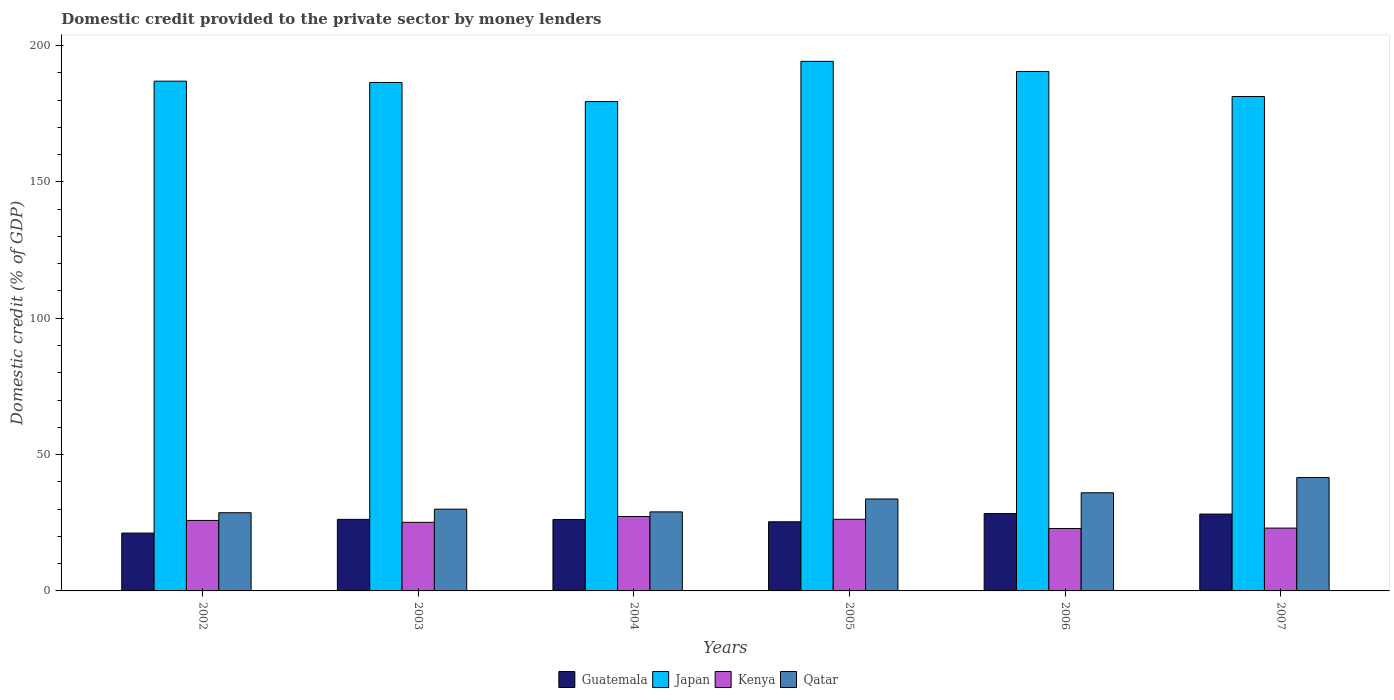Are the number of bars per tick equal to the number of legend labels?
Keep it short and to the point. Yes. What is the label of the 3rd group of bars from the left?
Your response must be concise. 2004. In how many cases, is the number of bars for a given year not equal to the number of legend labels?
Your answer should be very brief. 0. What is the domestic credit provided to the private sector by money lenders in Japan in 2004?
Your answer should be very brief. 179.48. Across all years, what is the maximum domestic credit provided to the private sector by money lenders in Guatemala?
Your answer should be very brief. 28.36. Across all years, what is the minimum domestic credit provided to the private sector by money lenders in Japan?
Your response must be concise. 179.48. In which year was the domestic credit provided to the private sector by money lenders in Japan minimum?
Your answer should be very brief. 2004. What is the total domestic credit provided to the private sector by money lenders in Qatar in the graph?
Give a very brief answer. 198.95. What is the difference between the domestic credit provided to the private sector by money lenders in Qatar in 2003 and that in 2004?
Provide a short and direct response. 1. What is the difference between the domestic credit provided to the private sector by money lenders in Guatemala in 2007 and the domestic credit provided to the private sector by money lenders in Japan in 2003?
Provide a short and direct response. -158.29. What is the average domestic credit provided to the private sector by money lenders in Kenya per year?
Your answer should be very brief. 25.08. In the year 2003, what is the difference between the domestic credit provided to the private sector by money lenders in Kenya and domestic credit provided to the private sector by money lenders in Qatar?
Your answer should be very brief. -4.83. In how many years, is the domestic credit provided to the private sector by money lenders in Guatemala greater than 120 %?
Provide a succinct answer. 0. What is the ratio of the domestic credit provided to the private sector by money lenders in Guatemala in 2002 to that in 2006?
Keep it short and to the point. 0.75. Is the domestic credit provided to the private sector by money lenders in Qatar in 2003 less than that in 2007?
Ensure brevity in your answer.  Yes. What is the difference between the highest and the second highest domestic credit provided to the private sector by money lenders in Qatar?
Provide a short and direct response. 5.58. What is the difference between the highest and the lowest domestic credit provided to the private sector by money lenders in Japan?
Your answer should be very brief. 14.74. Is the sum of the domestic credit provided to the private sector by money lenders in Japan in 2006 and 2007 greater than the maximum domestic credit provided to the private sector by money lenders in Qatar across all years?
Ensure brevity in your answer.  Yes. What does the 1st bar from the left in 2007 represents?
Provide a succinct answer. Guatemala. Is it the case that in every year, the sum of the domestic credit provided to the private sector by money lenders in Qatar and domestic credit provided to the private sector by money lenders in Guatemala is greater than the domestic credit provided to the private sector by money lenders in Japan?
Offer a very short reply. No. How many bars are there?
Ensure brevity in your answer.  24. Are all the bars in the graph horizontal?
Offer a very short reply. No. What is the difference between two consecutive major ticks on the Y-axis?
Provide a short and direct response. 50. How many legend labels are there?
Ensure brevity in your answer.  4. How are the legend labels stacked?
Ensure brevity in your answer.  Horizontal. What is the title of the graph?
Provide a succinct answer. Domestic credit provided to the private sector by money lenders. Does "Kyrgyz Republic" appear as one of the legend labels in the graph?
Provide a short and direct response. No. What is the label or title of the X-axis?
Keep it short and to the point. Years. What is the label or title of the Y-axis?
Make the answer very short. Domestic credit (% of GDP). What is the Domestic credit (% of GDP) in Guatemala in 2002?
Offer a terse response. 21.22. What is the Domestic credit (% of GDP) of Japan in 2002?
Give a very brief answer. 186.95. What is the Domestic credit (% of GDP) of Kenya in 2002?
Your answer should be very brief. 25.85. What is the Domestic credit (% of GDP) in Qatar in 2002?
Give a very brief answer. 28.68. What is the Domestic credit (% of GDP) in Guatemala in 2003?
Your answer should be very brief. 26.24. What is the Domestic credit (% of GDP) in Japan in 2003?
Offer a terse response. 186.47. What is the Domestic credit (% of GDP) in Kenya in 2003?
Ensure brevity in your answer.  25.16. What is the Domestic credit (% of GDP) of Qatar in 2003?
Offer a terse response. 29.99. What is the Domestic credit (% of GDP) in Guatemala in 2004?
Give a very brief answer. 26.2. What is the Domestic credit (% of GDP) of Japan in 2004?
Keep it short and to the point. 179.48. What is the Domestic credit (% of GDP) of Kenya in 2004?
Offer a terse response. 27.29. What is the Domestic credit (% of GDP) in Qatar in 2004?
Provide a succinct answer. 28.98. What is the Domestic credit (% of GDP) of Guatemala in 2005?
Provide a short and direct response. 25.36. What is the Domestic credit (% of GDP) in Japan in 2005?
Your response must be concise. 194.21. What is the Domestic credit (% of GDP) in Kenya in 2005?
Your answer should be compact. 26.28. What is the Domestic credit (% of GDP) in Qatar in 2005?
Make the answer very short. 33.72. What is the Domestic credit (% of GDP) of Guatemala in 2006?
Your answer should be compact. 28.36. What is the Domestic credit (% of GDP) in Japan in 2006?
Provide a succinct answer. 190.51. What is the Domestic credit (% of GDP) of Kenya in 2006?
Provide a succinct answer. 22.89. What is the Domestic credit (% of GDP) of Qatar in 2006?
Provide a succinct answer. 36. What is the Domestic credit (% of GDP) in Guatemala in 2007?
Offer a terse response. 28.18. What is the Domestic credit (% of GDP) of Japan in 2007?
Make the answer very short. 181.33. What is the Domestic credit (% of GDP) of Kenya in 2007?
Give a very brief answer. 23.04. What is the Domestic credit (% of GDP) in Qatar in 2007?
Keep it short and to the point. 41.58. Across all years, what is the maximum Domestic credit (% of GDP) of Guatemala?
Your response must be concise. 28.36. Across all years, what is the maximum Domestic credit (% of GDP) in Japan?
Your response must be concise. 194.21. Across all years, what is the maximum Domestic credit (% of GDP) of Kenya?
Your response must be concise. 27.29. Across all years, what is the maximum Domestic credit (% of GDP) in Qatar?
Your response must be concise. 41.58. Across all years, what is the minimum Domestic credit (% of GDP) in Guatemala?
Provide a succinct answer. 21.22. Across all years, what is the minimum Domestic credit (% of GDP) in Japan?
Keep it short and to the point. 179.48. Across all years, what is the minimum Domestic credit (% of GDP) of Kenya?
Your answer should be very brief. 22.89. Across all years, what is the minimum Domestic credit (% of GDP) of Qatar?
Ensure brevity in your answer.  28.68. What is the total Domestic credit (% of GDP) in Guatemala in the graph?
Your response must be concise. 155.56. What is the total Domestic credit (% of GDP) of Japan in the graph?
Your answer should be compact. 1118.95. What is the total Domestic credit (% of GDP) of Kenya in the graph?
Your answer should be very brief. 150.51. What is the total Domestic credit (% of GDP) in Qatar in the graph?
Give a very brief answer. 198.95. What is the difference between the Domestic credit (% of GDP) of Guatemala in 2002 and that in 2003?
Provide a succinct answer. -5.02. What is the difference between the Domestic credit (% of GDP) of Japan in 2002 and that in 2003?
Your answer should be very brief. 0.47. What is the difference between the Domestic credit (% of GDP) in Kenya in 2002 and that in 2003?
Provide a short and direct response. 0.7. What is the difference between the Domestic credit (% of GDP) in Qatar in 2002 and that in 2003?
Offer a very short reply. -1.31. What is the difference between the Domestic credit (% of GDP) in Guatemala in 2002 and that in 2004?
Your answer should be compact. -4.98. What is the difference between the Domestic credit (% of GDP) of Japan in 2002 and that in 2004?
Keep it short and to the point. 7.47. What is the difference between the Domestic credit (% of GDP) in Kenya in 2002 and that in 2004?
Your answer should be compact. -1.43. What is the difference between the Domestic credit (% of GDP) of Qatar in 2002 and that in 2004?
Offer a terse response. -0.31. What is the difference between the Domestic credit (% of GDP) of Guatemala in 2002 and that in 2005?
Ensure brevity in your answer.  -4.14. What is the difference between the Domestic credit (% of GDP) in Japan in 2002 and that in 2005?
Your response must be concise. -7.27. What is the difference between the Domestic credit (% of GDP) of Kenya in 2002 and that in 2005?
Your response must be concise. -0.42. What is the difference between the Domestic credit (% of GDP) in Qatar in 2002 and that in 2005?
Keep it short and to the point. -5.04. What is the difference between the Domestic credit (% of GDP) of Guatemala in 2002 and that in 2006?
Keep it short and to the point. -7.15. What is the difference between the Domestic credit (% of GDP) of Japan in 2002 and that in 2006?
Your answer should be compact. -3.56. What is the difference between the Domestic credit (% of GDP) in Kenya in 2002 and that in 2006?
Offer a terse response. 2.97. What is the difference between the Domestic credit (% of GDP) of Qatar in 2002 and that in 2006?
Make the answer very short. -7.32. What is the difference between the Domestic credit (% of GDP) in Guatemala in 2002 and that in 2007?
Offer a very short reply. -6.97. What is the difference between the Domestic credit (% of GDP) in Japan in 2002 and that in 2007?
Provide a succinct answer. 5.62. What is the difference between the Domestic credit (% of GDP) of Kenya in 2002 and that in 2007?
Offer a terse response. 2.81. What is the difference between the Domestic credit (% of GDP) in Qatar in 2002 and that in 2007?
Offer a very short reply. -12.9. What is the difference between the Domestic credit (% of GDP) of Guatemala in 2003 and that in 2004?
Provide a succinct answer. 0.04. What is the difference between the Domestic credit (% of GDP) of Japan in 2003 and that in 2004?
Your answer should be compact. 7. What is the difference between the Domestic credit (% of GDP) of Kenya in 2003 and that in 2004?
Provide a succinct answer. -2.13. What is the difference between the Domestic credit (% of GDP) of Guatemala in 2003 and that in 2005?
Provide a short and direct response. 0.88. What is the difference between the Domestic credit (% of GDP) of Japan in 2003 and that in 2005?
Keep it short and to the point. -7.74. What is the difference between the Domestic credit (% of GDP) in Kenya in 2003 and that in 2005?
Give a very brief answer. -1.12. What is the difference between the Domestic credit (% of GDP) in Qatar in 2003 and that in 2005?
Keep it short and to the point. -3.73. What is the difference between the Domestic credit (% of GDP) of Guatemala in 2003 and that in 2006?
Your answer should be compact. -2.12. What is the difference between the Domestic credit (% of GDP) of Japan in 2003 and that in 2006?
Your response must be concise. -4.03. What is the difference between the Domestic credit (% of GDP) in Kenya in 2003 and that in 2006?
Your response must be concise. 2.27. What is the difference between the Domestic credit (% of GDP) in Qatar in 2003 and that in 2006?
Give a very brief answer. -6.01. What is the difference between the Domestic credit (% of GDP) of Guatemala in 2003 and that in 2007?
Your response must be concise. -1.94. What is the difference between the Domestic credit (% of GDP) in Japan in 2003 and that in 2007?
Your answer should be very brief. 5.14. What is the difference between the Domestic credit (% of GDP) of Kenya in 2003 and that in 2007?
Give a very brief answer. 2.11. What is the difference between the Domestic credit (% of GDP) of Qatar in 2003 and that in 2007?
Give a very brief answer. -11.59. What is the difference between the Domestic credit (% of GDP) of Guatemala in 2004 and that in 2005?
Offer a very short reply. 0.84. What is the difference between the Domestic credit (% of GDP) of Japan in 2004 and that in 2005?
Offer a very short reply. -14.74. What is the difference between the Domestic credit (% of GDP) in Kenya in 2004 and that in 2005?
Keep it short and to the point. 1.01. What is the difference between the Domestic credit (% of GDP) of Qatar in 2004 and that in 2005?
Your answer should be compact. -4.74. What is the difference between the Domestic credit (% of GDP) of Guatemala in 2004 and that in 2006?
Your answer should be very brief. -2.16. What is the difference between the Domestic credit (% of GDP) of Japan in 2004 and that in 2006?
Keep it short and to the point. -11.03. What is the difference between the Domestic credit (% of GDP) in Kenya in 2004 and that in 2006?
Your response must be concise. 4.4. What is the difference between the Domestic credit (% of GDP) of Qatar in 2004 and that in 2006?
Make the answer very short. -7.01. What is the difference between the Domestic credit (% of GDP) of Guatemala in 2004 and that in 2007?
Your response must be concise. -1.98. What is the difference between the Domestic credit (% of GDP) of Japan in 2004 and that in 2007?
Make the answer very short. -1.85. What is the difference between the Domestic credit (% of GDP) in Kenya in 2004 and that in 2007?
Offer a terse response. 4.24. What is the difference between the Domestic credit (% of GDP) in Qatar in 2004 and that in 2007?
Ensure brevity in your answer.  -12.59. What is the difference between the Domestic credit (% of GDP) in Guatemala in 2005 and that in 2006?
Ensure brevity in your answer.  -3. What is the difference between the Domestic credit (% of GDP) of Japan in 2005 and that in 2006?
Make the answer very short. 3.71. What is the difference between the Domestic credit (% of GDP) in Kenya in 2005 and that in 2006?
Offer a very short reply. 3.39. What is the difference between the Domestic credit (% of GDP) in Qatar in 2005 and that in 2006?
Your answer should be very brief. -2.28. What is the difference between the Domestic credit (% of GDP) of Guatemala in 2005 and that in 2007?
Make the answer very short. -2.82. What is the difference between the Domestic credit (% of GDP) of Japan in 2005 and that in 2007?
Provide a short and direct response. 12.88. What is the difference between the Domestic credit (% of GDP) in Kenya in 2005 and that in 2007?
Provide a short and direct response. 3.23. What is the difference between the Domestic credit (% of GDP) of Qatar in 2005 and that in 2007?
Your response must be concise. -7.86. What is the difference between the Domestic credit (% of GDP) of Guatemala in 2006 and that in 2007?
Give a very brief answer. 0.18. What is the difference between the Domestic credit (% of GDP) of Japan in 2006 and that in 2007?
Your answer should be compact. 9.18. What is the difference between the Domestic credit (% of GDP) in Kenya in 2006 and that in 2007?
Offer a very short reply. -0.16. What is the difference between the Domestic credit (% of GDP) of Qatar in 2006 and that in 2007?
Offer a very short reply. -5.58. What is the difference between the Domestic credit (% of GDP) in Guatemala in 2002 and the Domestic credit (% of GDP) in Japan in 2003?
Offer a very short reply. -165.26. What is the difference between the Domestic credit (% of GDP) of Guatemala in 2002 and the Domestic credit (% of GDP) of Kenya in 2003?
Give a very brief answer. -3.94. What is the difference between the Domestic credit (% of GDP) in Guatemala in 2002 and the Domestic credit (% of GDP) in Qatar in 2003?
Your answer should be very brief. -8.77. What is the difference between the Domestic credit (% of GDP) in Japan in 2002 and the Domestic credit (% of GDP) in Kenya in 2003?
Ensure brevity in your answer.  161.79. What is the difference between the Domestic credit (% of GDP) in Japan in 2002 and the Domestic credit (% of GDP) in Qatar in 2003?
Your answer should be compact. 156.96. What is the difference between the Domestic credit (% of GDP) of Kenya in 2002 and the Domestic credit (% of GDP) of Qatar in 2003?
Offer a terse response. -4.13. What is the difference between the Domestic credit (% of GDP) of Guatemala in 2002 and the Domestic credit (% of GDP) of Japan in 2004?
Keep it short and to the point. -158.26. What is the difference between the Domestic credit (% of GDP) in Guatemala in 2002 and the Domestic credit (% of GDP) in Kenya in 2004?
Your answer should be very brief. -6.07. What is the difference between the Domestic credit (% of GDP) in Guatemala in 2002 and the Domestic credit (% of GDP) in Qatar in 2004?
Ensure brevity in your answer.  -7.77. What is the difference between the Domestic credit (% of GDP) of Japan in 2002 and the Domestic credit (% of GDP) of Kenya in 2004?
Give a very brief answer. 159.66. What is the difference between the Domestic credit (% of GDP) in Japan in 2002 and the Domestic credit (% of GDP) in Qatar in 2004?
Make the answer very short. 157.96. What is the difference between the Domestic credit (% of GDP) of Kenya in 2002 and the Domestic credit (% of GDP) of Qatar in 2004?
Give a very brief answer. -3.13. What is the difference between the Domestic credit (% of GDP) of Guatemala in 2002 and the Domestic credit (% of GDP) of Japan in 2005?
Your answer should be compact. -173. What is the difference between the Domestic credit (% of GDP) of Guatemala in 2002 and the Domestic credit (% of GDP) of Kenya in 2005?
Your response must be concise. -5.06. What is the difference between the Domestic credit (% of GDP) in Guatemala in 2002 and the Domestic credit (% of GDP) in Qatar in 2005?
Provide a succinct answer. -12.5. What is the difference between the Domestic credit (% of GDP) of Japan in 2002 and the Domestic credit (% of GDP) of Kenya in 2005?
Your response must be concise. 160.67. What is the difference between the Domestic credit (% of GDP) of Japan in 2002 and the Domestic credit (% of GDP) of Qatar in 2005?
Offer a very short reply. 153.23. What is the difference between the Domestic credit (% of GDP) in Kenya in 2002 and the Domestic credit (% of GDP) in Qatar in 2005?
Offer a terse response. -7.87. What is the difference between the Domestic credit (% of GDP) in Guatemala in 2002 and the Domestic credit (% of GDP) in Japan in 2006?
Make the answer very short. -169.29. What is the difference between the Domestic credit (% of GDP) of Guatemala in 2002 and the Domestic credit (% of GDP) of Kenya in 2006?
Make the answer very short. -1.67. What is the difference between the Domestic credit (% of GDP) in Guatemala in 2002 and the Domestic credit (% of GDP) in Qatar in 2006?
Provide a short and direct response. -14.78. What is the difference between the Domestic credit (% of GDP) in Japan in 2002 and the Domestic credit (% of GDP) in Kenya in 2006?
Offer a terse response. 164.06. What is the difference between the Domestic credit (% of GDP) in Japan in 2002 and the Domestic credit (% of GDP) in Qatar in 2006?
Offer a very short reply. 150.95. What is the difference between the Domestic credit (% of GDP) of Kenya in 2002 and the Domestic credit (% of GDP) of Qatar in 2006?
Keep it short and to the point. -10.14. What is the difference between the Domestic credit (% of GDP) of Guatemala in 2002 and the Domestic credit (% of GDP) of Japan in 2007?
Your answer should be very brief. -160.11. What is the difference between the Domestic credit (% of GDP) in Guatemala in 2002 and the Domestic credit (% of GDP) in Kenya in 2007?
Provide a short and direct response. -1.83. What is the difference between the Domestic credit (% of GDP) in Guatemala in 2002 and the Domestic credit (% of GDP) in Qatar in 2007?
Give a very brief answer. -20.36. What is the difference between the Domestic credit (% of GDP) of Japan in 2002 and the Domestic credit (% of GDP) of Kenya in 2007?
Provide a succinct answer. 163.9. What is the difference between the Domestic credit (% of GDP) of Japan in 2002 and the Domestic credit (% of GDP) of Qatar in 2007?
Make the answer very short. 145.37. What is the difference between the Domestic credit (% of GDP) in Kenya in 2002 and the Domestic credit (% of GDP) in Qatar in 2007?
Make the answer very short. -15.72. What is the difference between the Domestic credit (% of GDP) of Guatemala in 2003 and the Domestic credit (% of GDP) of Japan in 2004?
Your answer should be compact. -153.24. What is the difference between the Domestic credit (% of GDP) of Guatemala in 2003 and the Domestic credit (% of GDP) of Kenya in 2004?
Ensure brevity in your answer.  -1.05. What is the difference between the Domestic credit (% of GDP) of Guatemala in 2003 and the Domestic credit (% of GDP) of Qatar in 2004?
Offer a terse response. -2.75. What is the difference between the Domestic credit (% of GDP) of Japan in 2003 and the Domestic credit (% of GDP) of Kenya in 2004?
Provide a short and direct response. 159.19. What is the difference between the Domestic credit (% of GDP) of Japan in 2003 and the Domestic credit (% of GDP) of Qatar in 2004?
Provide a short and direct response. 157.49. What is the difference between the Domestic credit (% of GDP) of Kenya in 2003 and the Domestic credit (% of GDP) of Qatar in 2004?
Your answer should be compact. -3.83. What is the difference between the Domestic credit (% of GDP) of Guatemala in 2003 and the Domestic credit (% of GDP) of Japan in 2005?
Give a very brief answer. -167.97. What is the difference between the Domestic credit (% of GDP) of Guatemala in 2003 and the Domestic credit (% of GDP) of Kenya in 2005?
Your answer should be very brief. -0.04. What is the difference between the Domestic credit (% of GDP) of Guatemala in 2003 and the Domestic credit (% of GDP) of Qatar in 2005?
Your response must be concise. -7.48. What is the difference between the Domestic credit (% of GDP) in Japan in 2003 and the Domestic credit (% of GDP) in Kenya in 2005?
Provide a succinct answer. 160.2. What is the difference between the Domestic credit (% of GDP) of Japan in 2003 and the Domestic credit (% of GDP) of Qatar in 2005?
Offer a very short reply. 152.75. What is the difference between the Domestic credit (% of GDP) of Kenya in 2003 and the Domestic credit (% of GDP) of Qatar in 2005?
Your answer should be compact. -8.57. What is the difference between the Domestic credit (% of GDP) in Guatemala in 2003 and the Domestic credit (% of GDP) in Japan in 2006?
Make the answer very short. -164.27. What is the difference between the Domestic credit (% of GDP) in Guatemala in 2003 and the Domestic credit (% of GDP) in Kenya in 2006?
Give a very brief answer. 3.35. What is the difference between the Domestic credit (% of GDP) of Guatemala in 2003 and the Domestic credit (% of GDP) of Qatar in 2006?
Offer a very short reply. -9.76. What is the difference between the Domestic credit (% of GDP) of Japan in 2003 and the Domestic credit (% of GDP) of Kenya in 2006?
Offer a very short reply. 163.59. What is the difference between the Domestic credit (% of GDP) in Japan in 2003 and the Domestic credit (% of GDP) in Qatar in 2006?
Give a very brief answer. 150.48. What is the difference between the Domestic credit (% of GDP) in Kenya in 2003 and the Domestic credit (% of GDP) in Qatar in 2006?
Your answer should be compact. -10.84. What is the difference between the Domestic credit (% of GDP) in Guatemala in 2003 and the Domestic credit (% of GDP) in Japan in 2007?
Make the answer very short. -155.09. What is the difference between the Domestic credit (% of GDP) in Guatemala in 2003 and the Domestic credit (% of GDP) in Kenya in 2007?
Ensure brevity in your answer.  3.19. What is the difference between the Domestic credit (% of GDP) of Guatemala in 2003 and the Domestic credit (% of GDP) of Qatar in 2007?
Give a very brief answer. -15.34. What is the difference between the Domestic credit (% of GDP) of Japan in 2003 and the Domestic credit (% of GDP) of Kenya in 2007?
Offer a terse response. 163.43. What is the difference between the Domestic credit (% of GDP) in Japan in 2003 and the Domestic credit (% of GDP) in Qatar in 2007?
Give a very brief answer. 144.9. What is the difference between the Domestic credit (% of GDP) of Kenya in 2003 and the Domestic credit (% of GDP) of Qatar in 2007?
Provide a succinct answer. -16.42. What is the difference between the Domestic credit (% of GDP) in Guatemala in 2004 and the Domestic credit (% of GDP) in Japan in 2005?
Offer a very short reply. -168.01. What is the difference between the Domestic credit (% of GDP) of Guatemala in 2004 and the Domestic credit (% of GDP) of Kenya in 2005?
Make the answer very short. -0.08. What is the difference between the Domestic credit (% of GDP) in Guatemala in 2004 and the Domestic credit (% of GDP) in Qatar in 2005?
Ensure brevity in your answer.  -7.52. What is the difference between the Domestic credit (% of GDP) in Japan in 2004 and the Domestic credit (% of GDP) in Kenya in 2005?
Offer a very short reply. 153.2. What is the difference between the Domestic credit (% of GDP) in Japan in 2004 and the Domestic credit (% of GDP) in Qatar in 2005?
Your answer should be compact. 145.75. What is the difference between the Domestic credit (% of GDP) of Kenya in 2004 and the Domestic credit (% of GDP) of Qatar in 2005?
Your response must be concise. -6.43. What is the difference between the Domestic credit (% of GDP) of Guatemala in 2004 and the Domestic credit (% of GDP) of Japan in 2006?
Your answer should be very brief. -164.31. What is the difference between the Domestic credit (% of GDP) in Guatemala in 2004 and the Domestic credit (% of GDP) in Kenya in 2006?
Provide a succinct answer. 3.31. What is the difference between the Domestic credit (% of GDP) in Guatemala in 2004 and the Domestic credit (% of GDP) in Qatar in 2006?
Ensure brevity in your answer.  -9.8. What is the difference between the Domestic credit (% of GDP) in Japan in 2004 and the Domestic credit (% of GDP) in Kenya in 2006?
Make the answer very short. 156.59. What is the difference between the Domestic credit (% of GDP) of Japan in 2004 and the Domestic credit (% of GDP) of Qatar in 2006?
Make the answer very short. 143.48. What is the difference between the Domestic credit (% of GDP) of Kenya in 2004 and the Domestic credit (% of GDP) of Qatar in 2006?
Ensure brevity in your answer.  -8.71. What is the difference between the Domestic credit (% of GDP) of Guatemala in 2004 and the Domestic credit (% of GDP) of Japan in 2007?
Your answer should be very brief. -155.13. What is the difference between the Domestic credit (% of GDP) of Guatemala in 2004 and the Domestic credit (% of GDP) of Kenya in 2007?
Make the answer very short. 3.15. What is the difference between the Domestic credit (% of GDP) in Guatemala in 2004 and the Domestic credit (% of GDP) in Qatar in 2007?
Give a very brief answer. -15.38. What is the difference between the Domestic credit (% of GDP) of Japan in 2004 and the Domestic credit (% of GDP) of Kenya in 2007?
Your answer should be very brief. 156.43. What is the difference between the Domestic credit (% of GDP) of Japan in 2004 and the Domestic credit (% of GDP) of Qatar in 2007?
Ensure brevity in your answer.  137.9. What is the difference between the Domestic credit (% of GDP) in Kenya in 2004 and the Domestic credit (% of GDP) in Qatar in 2007?
Give a very brief answer. -14.29. What is the difference between the Domestic credit (% of GDP) in Guatemala in 2005 and the Domestic credit (% of GDP) in Japan in 2006?
Provide a short and direct response. -165.15. What is the difference between the Domestic credit (% of GDP) of Guatemala in 2005 and the Domestic credit (% of GDP) of Kenya in 2006?
Provide a succinct answer. 2.47. What is the difference between the Domestic credit (% of GDP) in Guatemala in 2005 and the Domestic credit (% of GDP) in Qatar in 2006?
Your answer should be compact. -10.64. What is the difference between the Domestic credit (% of GDP) of Japan in 2005 and the Domestic credit (% of GDP) of Kenya in 2006?
Offer a very short reply. 171.33. What is the difference between the Domestic credit (% of GDP) in Japan in 2005 and the Domestic credit (% of GDP) in Qatar in 2006?
Keep it short and to the point. 158.22. What is the difference between the Domestic credit (% of GDP) of Kenya in 2005 and the Domestic credit (% of GDP) of Qatar in 2006?
Keep it short and to the point. -9.72. What is the difference between the Domestic credit (% of GDP) in Guatemala in 2005 and the Domestic credit (% of GDP) in Japan in 2007?
Offer a terse response. -155.97. What is the difference between the Domestic credit (% of GDP) in Guatemala in 2005 and the Domestic credit (% of GDP) in Kenya in 2007?
Your answer should be compact. 2.32. What is the difference between the Domestic credit (% of GDP) of Guatemala in 2005 and the Domestic credit (% of GDP) of Qatar in 2007?
Provide a succinct answer. -16.22. What is the difference between the Domestic credit (% of GDP) in Japan in 2005 and the Domestic credit (% of GDP) in Kenya in 2007?
Your answer should be compact. 171.17. What is the difference between the Domestic credit (% of GDP) of Japan in 2005 and the Domestic credit (% of GDP) of Qatar in 2007?
Your answer should be very brief. 152.64. What is the difference between the Domestic credit (% of GDP) of Kenya in 2005 and the Domestic credit (% of GDP) of Qatar in 2007?
Offer a terse response. -15.3. What is the difference between the Domestic credit (% of GDP) of Guatemala in 2006 and the Domestic credit (% of GDP) of Japan in 2007?
Provide a short and direct response. -152.97. What is the difference between the Domestic credit (% of GDP) of Guatemala in 2006 and the Domestic credit (% of GDP) of Kenya in 2007?
Make the answer very short. 5.32. What is the difference between the Domestic credit (% of GDP) in Guatemala in 2006 and the Domestic credit (% of GDP) in Qatar in 2007?
Your answer should be compact. -13.21. What is the difference between the Domestic credit (% of GDP) of Japan in 2006 and the Domestic credit (% of GDP) of Kenya in 2007?
Keep it short and to the point. 167.46. What is the difference between the Domestic credit (% of GDP) in Japan in 2006 and the Domestic credit (% of GDP) in Qatar in 2007?
Your answer should be compact. 148.93. What is the difference between the Domestic credit (% of GDP) of Kenya in 2006 and the Domestic credit (% of GDP) of Qatar in 2007?
Offer a very short reply. -18.69. What is the average Domestic credit (% of GDP) in Guatemala per year?
Your response must be concise. 25.93. What is the average Domestic credit (% of GDP) of Japan per year?
Offer a very short reply. 186.49. What is the average Domestic credit (% of GDP) of Kenya per year?
Offer a very short reply. 25.08. What is the average Domestic credit (% of GDP) of Qatar per year?
Ensure brevity in your answer.  33.16. In the year 2002, what is the difference between the Domestic credit (% of GDP) of Guatemala and Domestic credit (% of GDP) of Japan?
Provide a succinct answer. -165.73. In the year 2002, what is the difference between the Domestic credit (% of GDP) in Guatemala and Domestic credit (% of GDP) in Kenya?
Provide a short and direct response. -4.64. In the year 2002, what is the difference between the Domestic credit (% of GDP) in Guatemala and Domestic credit (% of GDP) in Qatar?
Offer a terse response. -7.46. In the year 2002, what is the difference between the Domestic credit (% of GDP) in Japan and Domestic credit (% of GDP) in Kenya?
Provide a short and direct response. 161.09. In the year 2002, what is the difference between the Domestic credit (% of GDP) in Japan and Domestic credit (% of GDP) in Qatar?
Provide a succinct answer. 158.27. In the year 2002, what is the difference between the Domestic credit (% of GDP) of Kenya and Domestic credit (% of GDP) of Qatar?
Ensure brevity in your answer.  -2.82. In the year 2003, what is the difference between the Domestic credit (% of GDP) of Guatemala and Domestic credit (% of GDP) of Japan?
Offer a terse response. -160.23. In the year 2003, what is the difference between the Domestic credit (% of GDP) of Guatemala and Domestic credit (% of GDP) of Kenya?
Ensure brevity in your answer.  1.08. In the year 2003, what is the difference between the Domestic credit (% of GDP) in Guatemala and Domestic credit (% of GDP) in Qatar?
Your answer should be very brief. -3.75. In the year 2003, what is the difference between the Domestic credit (% of GDP) in Japan and Domestic credit (% of GDP) in Kenya?
Make the answer very short. 161.32. In the year 2003, what is the difference between the Domestic credit (% of GDP) of Japan and Domestic credit (% of GDP) of Qatar?
Ensure brevity in your answer.  156.49. In the year 2003, what is the difference between the Domestic credit (% of GDP) in Kenya and Domestic credit (% of GDP) in Qatar?
Provide a succinct answer. -4.83. In the year 2004, what is the difference between the Domestic credit (% of GDP) of Guatemala and Domestic credit (% of GDP) of Japan?
Your answer should be very brief. -153.28. In the year 2004, what is the difference between the Domestic credit (% of GDP) of Guatemala and Domestic credit (% of GDP) of Kenya?
Offer a terse response. -1.09. In the year 2004, what is the difference between the Domestic credit (% of GDP) in Guatemala and Domestic credit (% of GDP) in Qatar?
Ensure brevity in your answer.  -2.79. In the year 2004, what is the difference between the Domestic credit (% of GDP) of Japan and Domestic credit (% of GDP) of Kenya?
Your answer should be compact. 152.19. In the year 2004, what is the difference between the Domestic credit (% of GDP) in Japan and Domestic credit (% of GDP) in Qatar?
Ensure brevity in your answer.  150.49. In the year 2004, what is the difference between the Domestic credit (% of GDP) of Kenya and Domestic credit (% of GDP) of Qatar?
Offer a very short reply. -1.7. In the year 2005, what is the difference between the Domestic credit (% of GDP) in Guatemala and Domestic credit (% of GDP) in Japan?
Offer a terse response. -168.85. In the year 2005, what is the difference between the Domestic credit (% of GDP) in Guatemala and Domestic credit (% of GDP) in Kenya?
Offer a terse response. -0.92. In the year 2005, what is the difference between the Domestic credit (% of GDP) of Guatemala and Domestic credit (% of GDP) of Qatar?
Make the answer very short. -8.36. In the year 2005, what is the difference between the Domestic credit (% of GDP) of Japan and Domestic credit (% of GDP) of Kenya?
Provide a short and direct response. 167.94. In the year 2005, what is the difference between the Domestic credit (% of GDP) of Japan and Domestic credit (% of GDP) of Qatar?
Keep it short and to the point. 160.49. In the year 2005, what is the difference between the Domestic credit (% of GDP) in Kenya and Domestic credit (% of GDP) in Qatar?
Your answer should be very brief. -7.44. In the year 2006, what is the difference between the Domestic credit (% of GDP) of Guatemala and Domestic credit (% of GDP) of Japan?
Your response must be concise. -162.14. In the year 2006, what is the difference between the Domestic credit (% of GDP) in Guatemala and Domestic credit (% of GDP) in Kenya?
Ensure brevity in your answer.  5.48. In the year 2006, what is the difference between the Domestic credit (% of GDP) of Guatemala and Domestic credit (% of GDP) of Qatar?
Offer a terse response. -7.63. In the year 2006, what is the difference between the Domestic credit (% of GDP) in Japan and Domestic credit (% of GDP) in Kenya?
Make the answer very short. 167.62. In the year 2006, what is the difference between the Domestic credit (% of GDP) in Japan and Domestic credit (% of GDP) in Qatar?
Your answer should be compact. 154.51. In the year 2006, what is the difference between the Domestic credit (% of GDP) in Kenya and Domestic credit (% of GDP) in Qatar?
Ensure brevity in your answer.  -13.11. In the year 2007, what is the difference between the Domestic credit (% of GDP) in Guatemala and Domestic credit (% of GDP) in Japan?
Your answer should be very brief. -153.15. In the year 2007, what is the difference between the Domestic credit (% of GDP) in Guatemala and Domestic credit (% of GDP) in Kenya?
Keep it short and to the point. 5.14. In the year 2007, what is the difference between the Domestic credit (% of GDP) in Guatemala and Domestic credit (% of GDP) in Qatar?
Make the answer very short. -13.39. In the year 2007, what is the difference between the Domestic credit (% of GDP) in Japan and Domestic credit (% of GDP) in Kenya?
Offer a terse response. 158.28. In the year 2007, what is the difference between the Domestic credit (% of GDP) of Japan and Domestic credit (% of GDP) of Qatar?
Offer a terse response. 139.75. In the year 2007, what is the difference between the Domestic credit (% of GDP) of Kenya and Domestic credit (% of GDP) of Qatar?
Offer a very short reply. -18.53. What is the ratio of the Domestic credit (% of GDP) of Guatemala in 2002 to that in 2003?
Offer a very short reply. 0.81. What is the ratio of the Domestic credit (% of GDP) in Kenya in 2002 to that in 2003?
Your answer should be compact. 1.03. What is the ratio of the Domestic credit (% of GDP) of Qatar in 2002 to that in 2003?
Provide a short and direct response. 0.96. What is the ratio of the Domestic credit (% of GDP) in Guatemala in 2002 to that in 2004?
Offer a terse response. 0.81. What is the ratio of the Domestic credit (% of GDP) of Japan in 2002 to that in 2004?
Make the answer very short. 1.04. What is the ratio of the Domestic credit (% of GDP) of Kenya in 2002 to that in 2004?
Offer a terse response. 0.95. What is the ratio of the Domestic credit (% of GDP) of Guatemala in 2002 to that in 2005?
Make the answer very short. 0.84. What is the ratio of the Domestic credit (% of GDP) of Japan in 2002 to that in 2005?
Keep it short and to the point. 0.96. What is the ratio of the Domestic credit (% of GDP) of Kenya in 2002 to that in 2005?
Provide a short and direct response. 0.98. What is the ratio of the Domestic credit (% of GDP) of Qatar in 2002 to that in 2005?
Your answer should be very brief. 0.85. What is the ratio of the Domestic credit (% of GDP) in Guatemala in 2002 to that in 2006?
Ensure brevity in your answer.  0.75. What is the ratio of the Domestic credit (% of GDP) in Japan in 2002 to that in 2006?
Provide a succinct answer. 0.98. What is the ratio of the Domestic credit (% of GDP) in Kenya in 2002 to that in 2006?
Offer a very short reply. 1.13. What is the ratio of the Domestic credit (% of GDP) in Qatar in 2002 to that in 2006?
Ensure brevity in your answer.  0.8. What is the ratio of the Domestic credit (% of GDP) in Guatemala in 2002 to that in 2007?
Provide a succinct answer. 0.75. What is the ratio of the Domestic credit (% of GDP) of Japan in 2002 to that in 2007?
Provide a succinct answer. 1.03. What is the ratio of the Domestic credit (% of GDP) in Kenya in 2002 to that in 2007?
Offer a very short reply. 1.12. What is the ratio of the Domestic credit (% of GDP) of Qatar in 2002 to that in 2007?
Offer a terse response. 0.69. What is the ratio of the Domestic credit (% of GDP) of Guatemala in 2003 to that in 2004?
Ensure brevity in your answer.  1. What is the ratio of the Domestic credit (% of GDP) of Japan in 2003 to that in 2004?
Provide a short and direct response. 1.04. What is the ratio of the Domestic credit (% of GDP) of Kenya in 2003 to that in 2004?
Keep it short and to the point. 0.92. What is the ratio of the Domestic credit (% of GDP) of Qatar in 2003 to that in 2004?
Offer a very short reply. 1.03. What is the ratio of the Domestic credit (% of GDP) of Guatemala in 2003 to that in 2005?
Make the answer very short. 1.03. What is the ratio of the Domestic credit (% of GDP) of Japan in 2003 to that in 2005?
Provide a short and direct response. 0.96. What is the ratio of the Domestic credit (% of GDP) of Kenya in 2003 to that in 2005?
Your response must be concise. 0.96. What is the ratio of the Domestic credit (% of GDP) of Qatar in 2003 to that in 2005?
Your answer should be compact. 0.89. What is the ratio of the Domestic credit (% of GDP) of Guatemala in 2003 to that in 2006?
Give a very brief answer. 0.93. What is the ratio of the Domestic credit (% of GDP) of Japan in 2003 to that in 2006?
Provide a short and direct response. 0.98. What is the ratio of the Domestic credit (% of GDP) in Kenya in 2003 to that in 2006?
Your answer should be compact. 1.1. What is the ratio of the Domestic credit (% of GDP) in Qatar in 2003 to that in 2006?
Provide a short and direct response. 0.83. What is the ratio of the Domestic credit (% of GDP) of Guatemala in 2003 to that in 2007?
Keep it short and to the point. 0.93. What is the ratio of the Domestic credit (% of GDP) in Japan in 2003 to that in 2007?
Offer a terse response. 1.03. What is the ratio of the Domestic credit (% of GDP) in Kenya in 2003 to that in 2007?
Provide a short and direct response. 1.09. What is the ratio of the Domestic credit (% of GDP) in Qatar in 2003 to that in 2007?
Your response must be concise. 0.72. What is the ratio of the Domestic credit (% of GDP) in Guatemala in 2004 to that in 2005?
Your response must be concise. 1.03. What is the ratio of the Domestic credit (% of GDP) of Japan in 2004 to that in 2005?
Your answer should be compact. 0.92. What is the ratio of the Domestic credit (% of GDP) of Qatar in 2004 to that in 2005?
Your response must be concise. 0.86. What is the ratio of the Domestic credit (% of GDP) of Guatemala in 2004 to that in 2006?
Your answer should be very brief. 0.92. What is the ratio of the Domestic credit (% of GDP) of Japan in 2004 to that in 2006?
Make the answer very short. 0.94. What is the ratio of the Domestic credit (% of GDP) in Kenya in 2004 to that in 2006?
Keep it short and to the point. 1.19. What is the ratio of the Domestic credit (% of GDP) in Qatar in 2004 to that in 2006?
Keep it short and to the point. 0.81. What is the ratio of the Domestic credit (% of GDP) in Guatemala in 2004 to that in 2007?
Your answer should be compact. 0.93. What is the ratio of the Domestic credit (% of GDP) of Japan in 2004 to that in 2007?
Provide a succinct answer. 0.99. What is the ratio of the Domestic credit (% of GDP) of Kenya in 2004 to that in 2007?
Make the answer very short. 1.18. What is the ratio of the Domestic credit (% of GDP) in Qatar in 2004 to that in 2007?
Your response must be concise. 0.7. What is the ratio of the Domestic credit (% of GDP) in Guatemala in 2005 to that in 2006?
Keep it short and to the point. 0.89. What is the ratio of the Domestic credit (% of GDP) in Japan in 2005 to that in 2006?
Offer a terse response. 1.02. What is the ratio of the Domestic credit (% of GDP) of Kenya in 2005 to that in 2006?
Your answer should be very brief. 1.15. What is the ratio of the Domestic credit (% of GDP) in Qatar in 2005 to that in 2006?
Offer a very short reply. 0.94. What is the ratio of the Domestic credit (% of GDP) of Guatemala in 2005 to that in 2007?
Offer a terse response. 0.9. What is the ratio of the Domestic credit (% of GDP) of Japan in 2005 to that in 2007?
Provide a succinct answer. 1.07. What is the ratio of the Domestic credit (% of GDP) of Kenya in 2005 to that in 2007?
Your answer should be compact. 1.14. What is the ratio of the Domestic credit (% of GDP) in Qatar in 2005 to that in 2007?
Provide a succinct answer. 0.81. What is the ratio of the Domestic credit (% of GDP) in Guatemala in 2006 to that in 2007?
Your response must be concise. 1.01. What is the ratio of the Domestic credit (% of GDP) in Japan in 2006 to that in 2007?
Offer a terse response. 1.05. What is the ratio of the Domestic credit (% of GDP) in Qatar in 2006 to that in 2007?
Provide a short and direct response. 0.87. What is the difference between the highest and the second highest Domestic credit (% of GDP) of Guatemala?
Offer a very short reply. 0.18. What is the difference between the highest and the second highest Domestic credit (% of GDP) of Japan?
Offer a terse response. 3.71. What is the difference between the highest and the second highest Domestic credit (% of GDP) in Kenya?
Provide a short and direct response. 1.01. What is the difference between the highest and the second highest Domestic credit (% of GDP) in Qatar?
Offer a very short reply. 5.58. What is the difference between the highest and the lowest Domestic credit (% of GDP) of Guatemala?
Your answer should be compact. 7.15. What is the difference between the highest and the lowest Domestic credit (% of GDP) in Japan?
Provide a short and direct response. 14.74. What is the difference between the highest and the lowest Domestic credit (% of GDP) of Kenya?
Provide a succinct answer. 4.4. What is the difference between the highest and the lowest Domestic credit (% of GDP) of Qatar?
Make the answer very short. 12.9. 